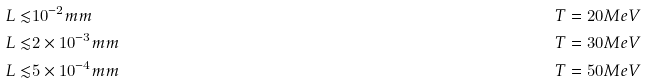Convert formula to latex. <formula><loc_0><loc_0><loc_500><loc_500>L \lesssim & 1 0 ^ { - 2 } m m & \quad & T = 2 0 M e V \\ L \lesssim & 2 \times 1 0 ^ { - 3 } m m & \quad & T = 3 0 M e V \\ L \lesssim & 5 \times 1 0 ^ { - 4 } m m & \quad & T = 5 0 M e V</formula> 